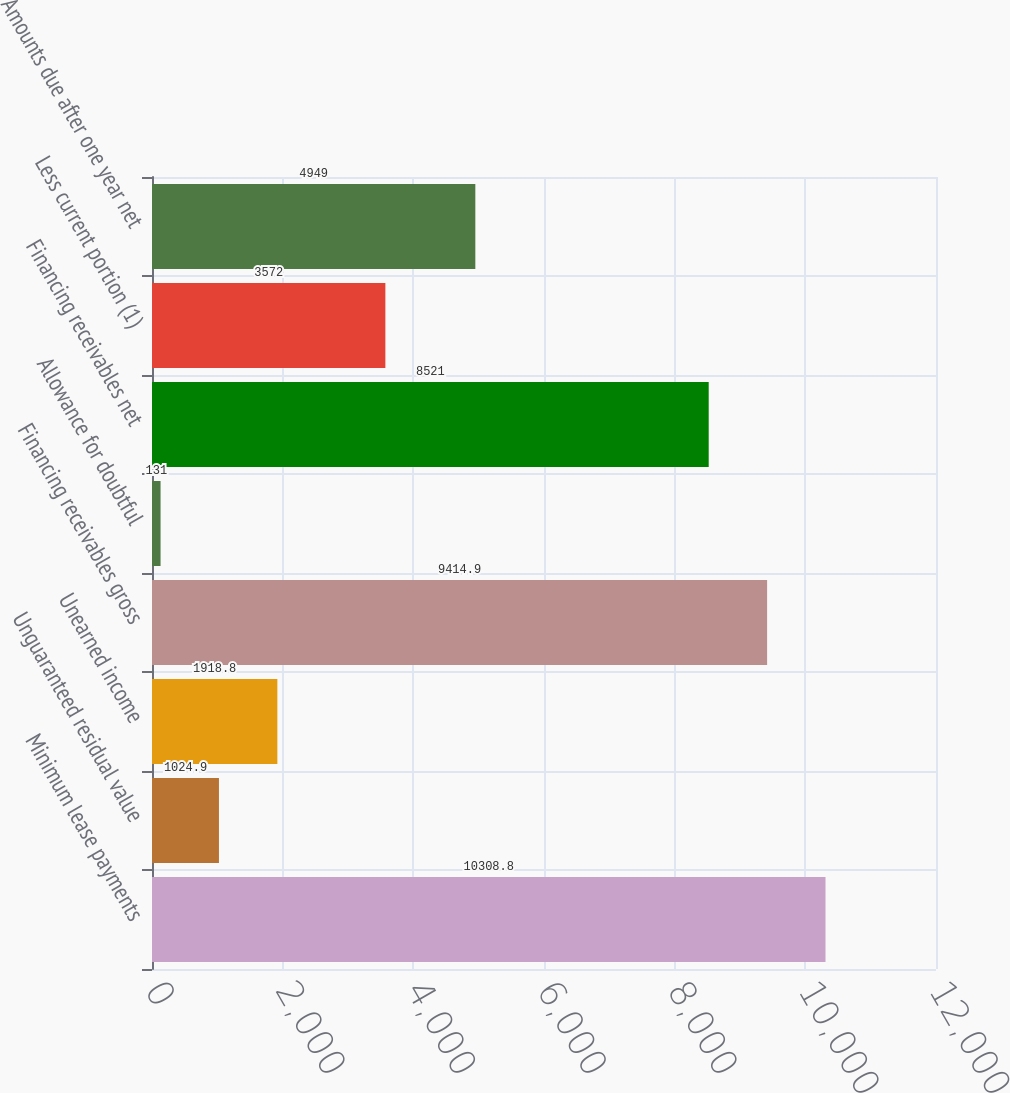<chart> <loc_0><loc_0><loc_500><loc_500><bar_chart><fcel>Minimum lease payments<fcel>Unguaranteed residual value<fcel>Unearned income<fcel>Financing receivables gross<fcel>Allowance for doubtful<fcel>Financing receivables net<fcel>Less current portion (1)<fcel>Amounts due after one year net<nl><fcel>10308.8<fcel>1024.9<fcel>1918.8<fcel>9414.9<fcel>131<fcel>8521<fcel>3572<fcel>4949<nl></chart> 